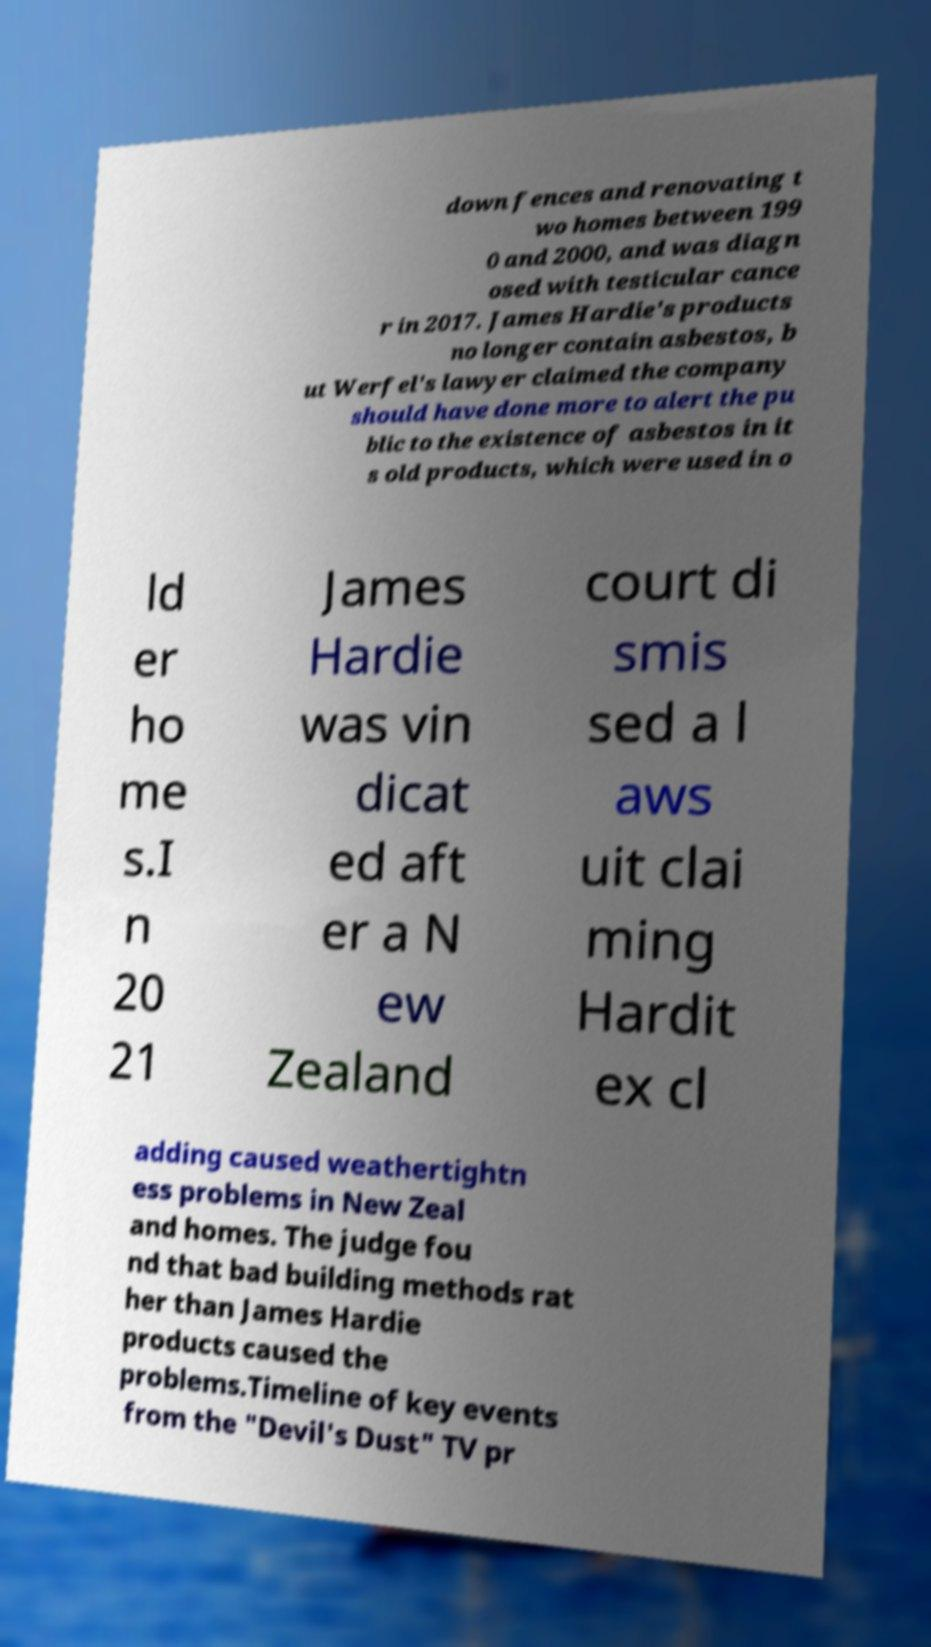Could you extract and type out the text from this image? down fences and renovating t wo homes between 199 0 and 2000, and was diagn osed with testicular cance r in 2017. James Hardie's products no longer contain asbestos, b ut Werfel's lawyer claimed the company should have done more to alert the pu blic to the existence of asbestos in it s old products, which were used in o ld er ho me s.I n 20 21 James Hardie was vin dicat ed aft er a N ew Zealand court di smis sed a l aws uit clai ming Hardit ex cl adding caused weathertightn ess problems in New Zeal and homes. The judge fou nd that bad building methods rat her than James Hardie products caused the problems.Timeline of key events from the "Devil's Dust" TV pr 